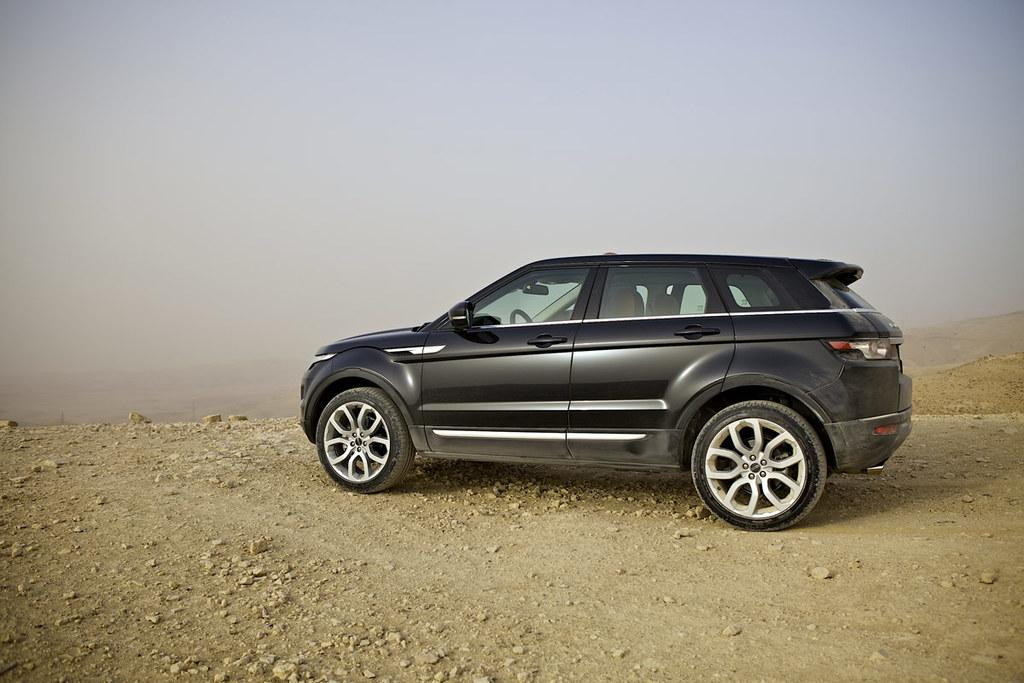What type of natural formation can be seen in the image? There are mountains in the image. What type of vehicle is present on the ground in the image? There is a black car on the ground in the image. What type of terrain is visible on the ground in the image? There are rocks and sand on the ground in the image. What is visible at the top of the image? The sky is visible at the top of the image. Can you see any arms or mittens on the mountains in the image? There are no arms or mittens present on the mountains in the image; it features a natural landscape with mountains, rocks, sand, and a black car. Is there a ghost visible in the image? There is no ghost present in the image; it features a natural landscape with mountains, rocks, sand, and a black car. 